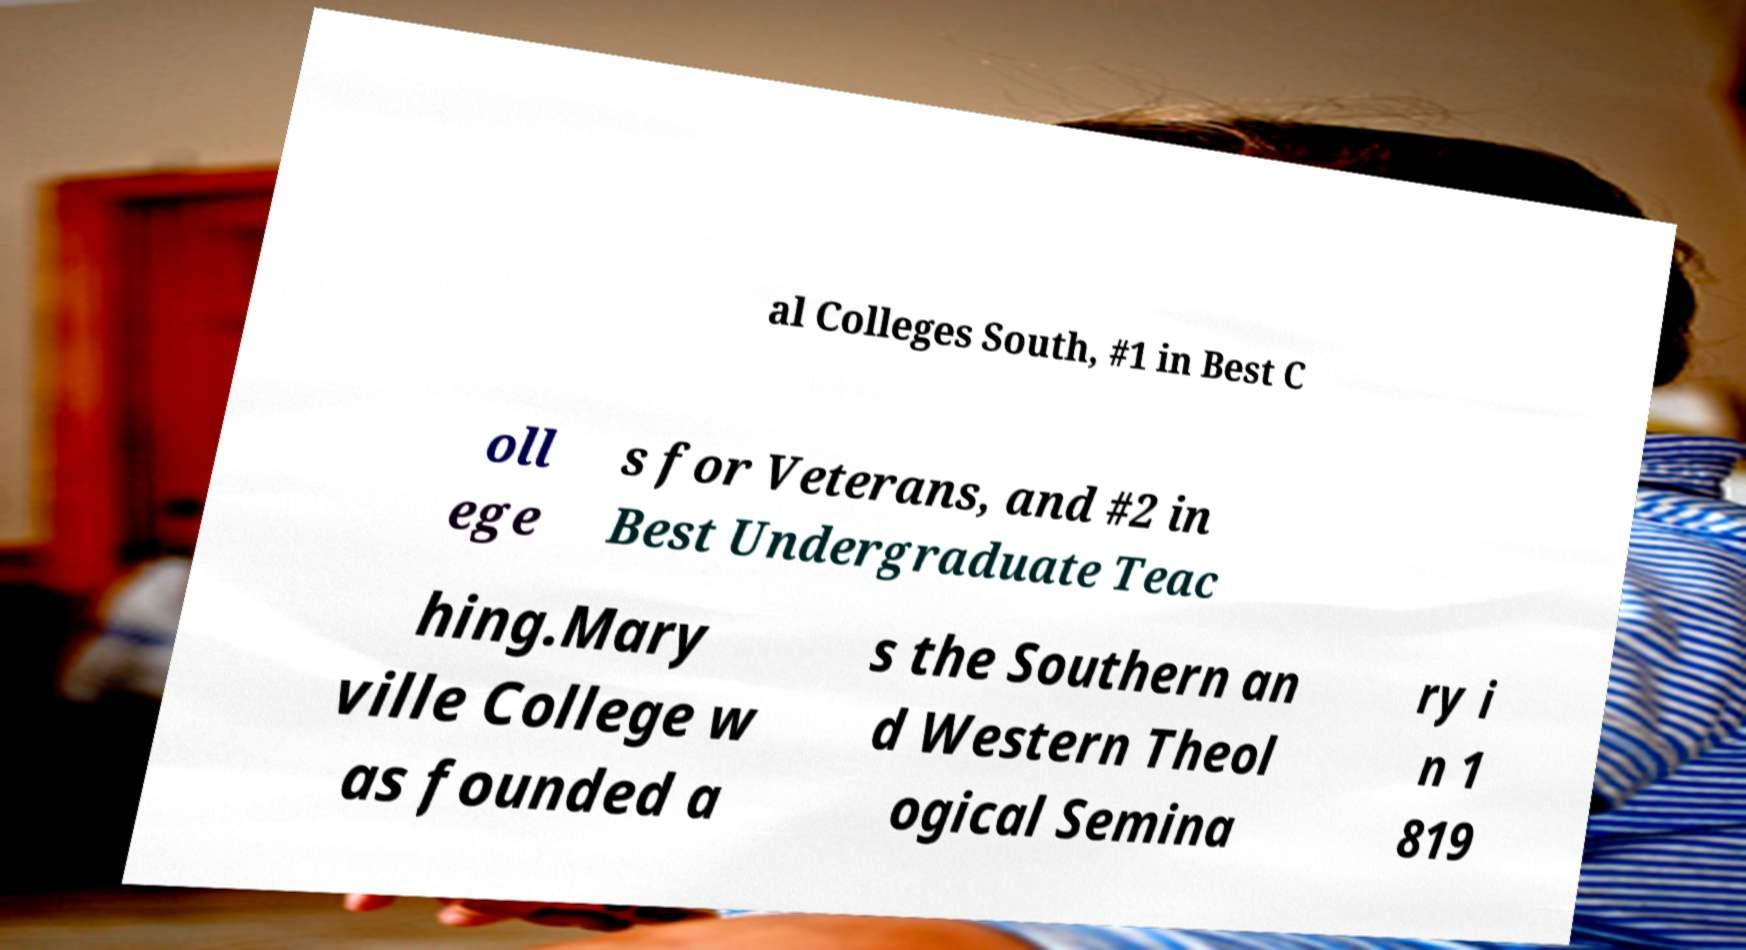Can you read and provide the text displayed in the image?This photo seems to have some interesting text. Can you extract and type it out for me? al Colleges South, #1 in Best C oll ege s for Veterans, and #2 in Best Undergraduate Teac hing.Mary ville College w as founded a s the Southern an d Western Theol ogical Semina ry i n 1 819 